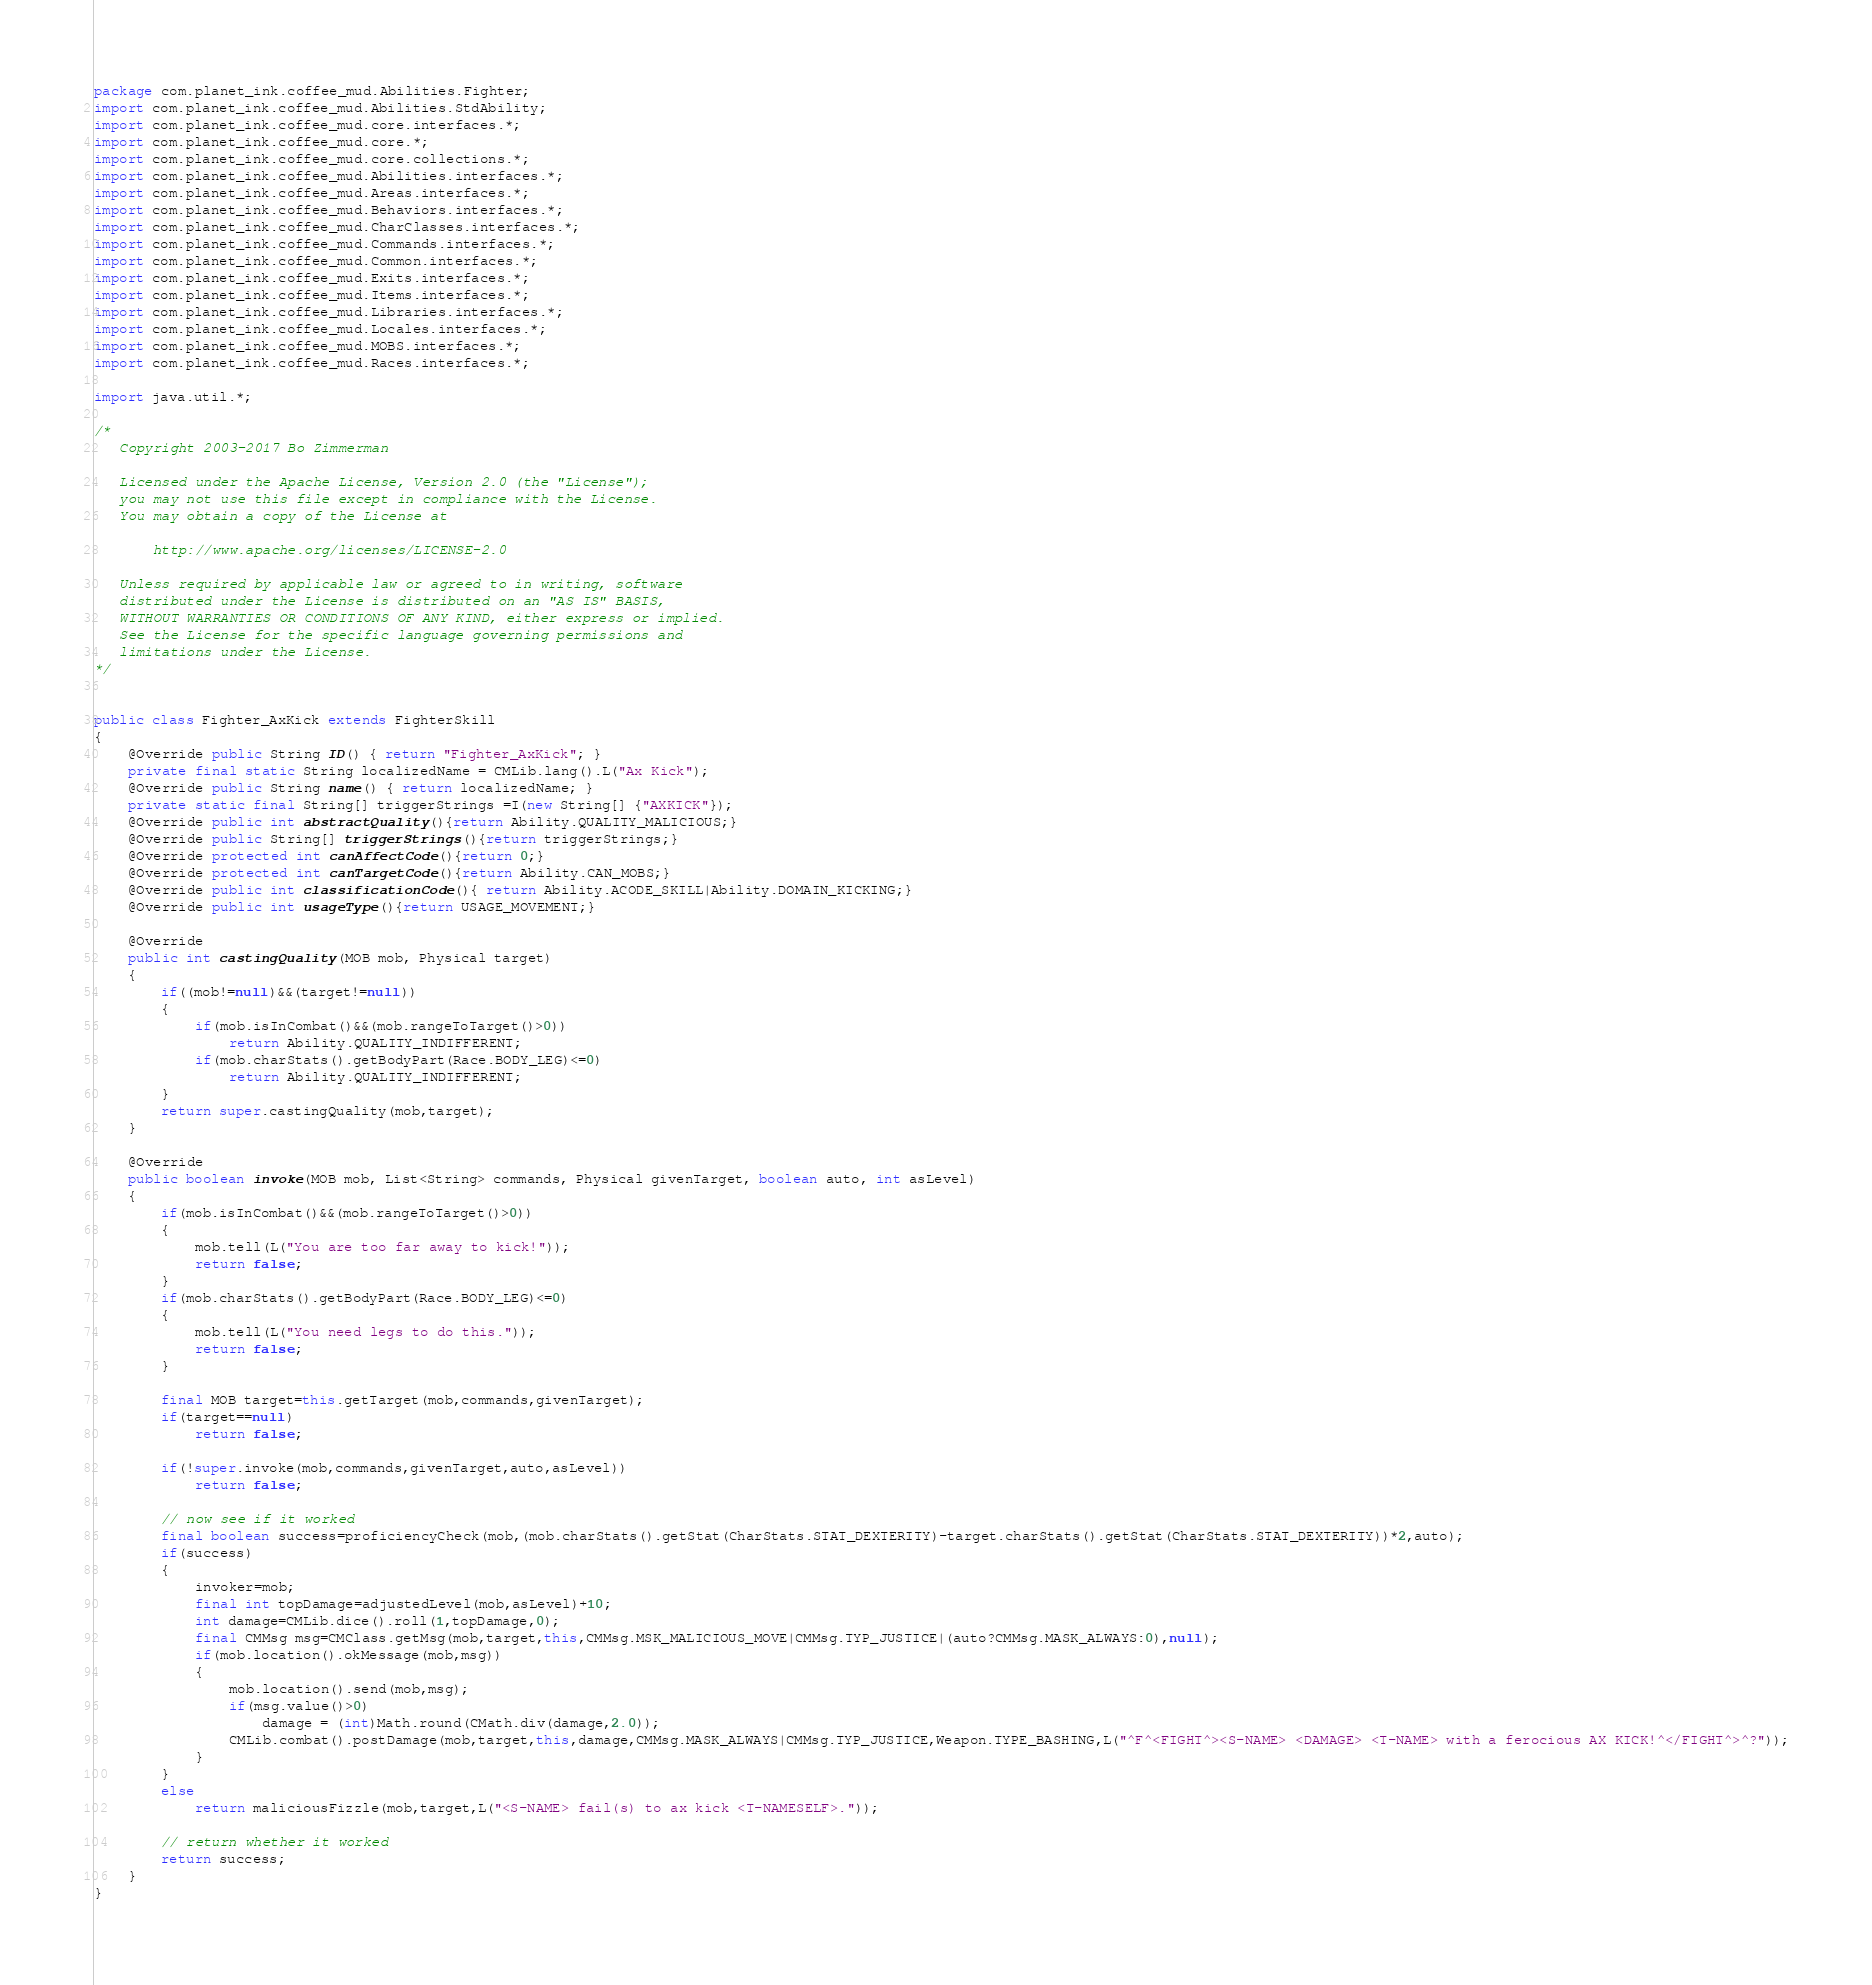<code> <loc_0><loc_0><loc_500><loc_500><_Java_>package com.planet_ink.coffee_mud.Abilities.Fighter;
import com.planet_ink.coffee_mud.Abilities.StdAbility;
import com.planet_ink.coffee_mud.core.interfaces.*;
import com.planet_ink.coffee_mud.core.*;
import com.planet_ink.coffee_mud.core.collections.*;
import com.planet_ink.coffee_mud.Abilities.interfaces.*;
import com.planet_ink.coffee_mud.Areas.interfaces.*;
import com.planet_ink.coffee_mud.Behaviors.interfaces.*;
import com.planet_ink.coffee_mud.CharClasses.interfaces.*;
import com.planet_ink.coffee_mud.Commands.interfaces.*;
import com.planet_ink.coffee_mud.Common.interfaces.*;
import com.planet_ink.coffee_mud.Exits.interfaces.*;
import com.planet_ink.coffee_mud.Items.interfaces.*;
import com.planet_ink.coffee_mud.Libraries.interfaces.*;
import com.planet_ink.coffee_mud.Locales.interfaces.*;
import com.planet_ink.coffee_mud.MOBS.interfaces.*;
import com.planet_ink.coffee_mud.Races.interfaces.*;

import java.util.*;

/*
   Copyright 2003-2017 Bo Zimmerman

   Licensed under the Apache License, Version 2.0 (the "License");
   you may not use this file except in compliance with the License.
   You may obtain a copy of the License at

	   http://www.apache.org/licenses/LICENSE-2.0

   Unless required by applicable law or agreed to in writing, software
   distributed under the License is distributed on an "AS IS" BASIS,
   WITHOUT WARRANTIES OR CONDITIONS OF ANY KIND, either express or implied.
   See the License for the specific language governing permissions and
   limitations under the License.
*/


public class Fighter_AxKick extends FighterSkill
{
	@Override public String ID() { return "Fighter_AxKick"; }
	private final static String localizedName = CMLib.lang().L("Ax Kick");
	@Override public String name() { return localizedName; }
	private static final String[] triggerStrings =I(new String[] {"AXKICK"});
	@Override public int abstractQuality(){return Ability.QUALITY_MALICIOUS;}
	@Override public String[] triggerStrings(){return triggerStrings;}
	@Override protected int canAffectCode(){return 0;}
	@Override protected int canTargetCode(){return Ability.CAN_MOBS;}
	@Override public int classificationCode(){ return Ability.ACODE_SKILL|Ability.DOMAIN_KICKING;}
	@Override public int usageType(){return USAGE_MOVEMENT;}

	@Override
	public int castingQuality(MOB mob, Physical target)
	{
		if((mob!=null)&&(target!=null))
		{
			if(mob.isInCombat()&&(mob.rangeToTarget()>0))
				return Ability.QUALITY_INDIFFERENT;
			if(mob.charStats().getBodyPart(Race.BODY_LEG)<=0)
				return Ability.QUALITY_INDIFFERENT;
		}
		return super.castingQuality(mob,target);
	}

	@Override
	public boolean invoke(MOB mob, List<String> commands, Physical givenTarget, boolean auto, int asLevel)
	{
		if(mob.isInCombat()&&(mob.rangeToTarget()>0))
		{
			mob.tell(L("You are too far away to kick!"));
			return false;
		}
		if(mob.charStats().getBodyPart(Race.BODY_LEG)<=0)
		{
			mob.tell(L("You need legs to do this."));
			return false;
		}

		final MOB target=this.getTarget(mob,commands,givenTarget);
		if(target==null)
			return false;

		if(!super.invoke(mob,commands,givenTarget,auto,asLevel))
			return false;

		// now see if it worked
		final boolean success=proficiencyCheck(mob,(mob.charStats().getStat(CharStats.STAT_DEXTERITY)-target.charStats().getStat(CharStats.STAT_DEXTERITY))*2,auto);
		if(success)
		{
			invoker=mob;
			final int topDamage=adjustedLevel(mob,asLevel)+10;
			int damage=CMLib.dice().roll(1,topDamage,0);
			final CMMsg msg=CMClass.getMsg(mob,target,this,CMMsg.MSK_MALICIOUS_MOVE|CMMsg.TYP_JUSTICE|(auto?CMMsg.MASK_ALWAYS:0),null);
			if(mob.location().okMessage(mob,msg))
			{
				mob.location().send(mob,msg);
				if(msg.value()>0)
					damage = (int)Math.round(CMath.div(damage,2.0));
				CMLib.combat().postDamage(mob,target,this,damage,CMMsg.MASK_ALWAYS|CMMsg.TYP_JUSTICE,Weapon.TYPE_BASHING,L("^F^<FIGHT^><S-NAME> <DAMAGE> <T-NAME> with a ferocious AX KICK!^</FIGHT^>^?"));
			}
		}
		else
			return maliciousFizzle(mob,target,L("<S-NAME> fail(s) to ax kick <T-NAMESELF>."));

		// return whether it worked
		return success;
	}
}
</code> 